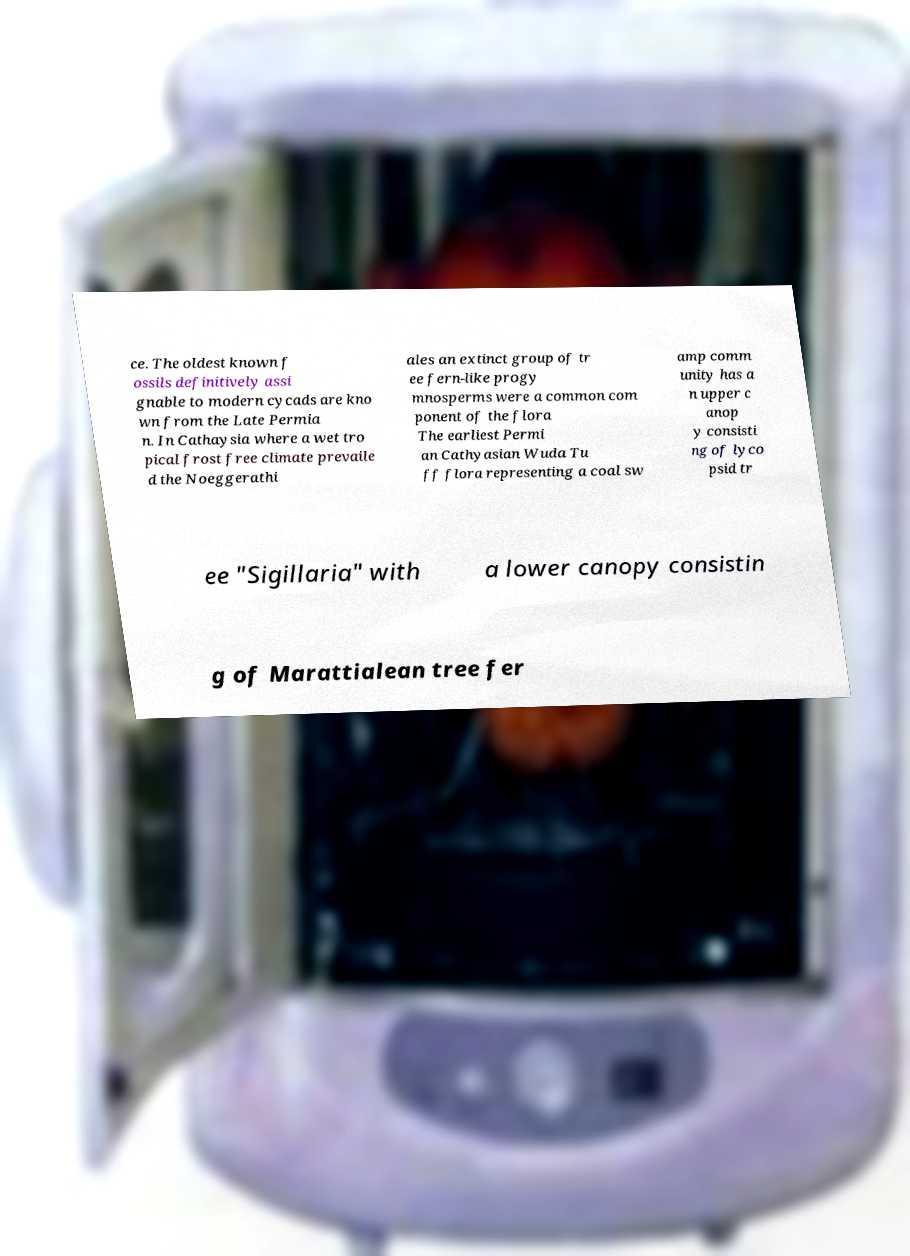I need the written content from this picture converted into text. Can you do that? ce. The oldest known f ossils definitively assi gnable to modern cycads are kno wn from the Late Permia n. In Cathaysia where a wet tro pical frost free climate prevaile d the Noeggerathi ales an extinct group of tr ee fern-like progy mnosperms were a common com ponent of the flora The earliest Permi an Cathyasian Wuda Tu ff flora representing a coal sw amp comm unity has a n upper c anop y consisti ng of lyco psid tr ee "Sigillaria" with a lower canopy consistin g of Marattialean tree fer 